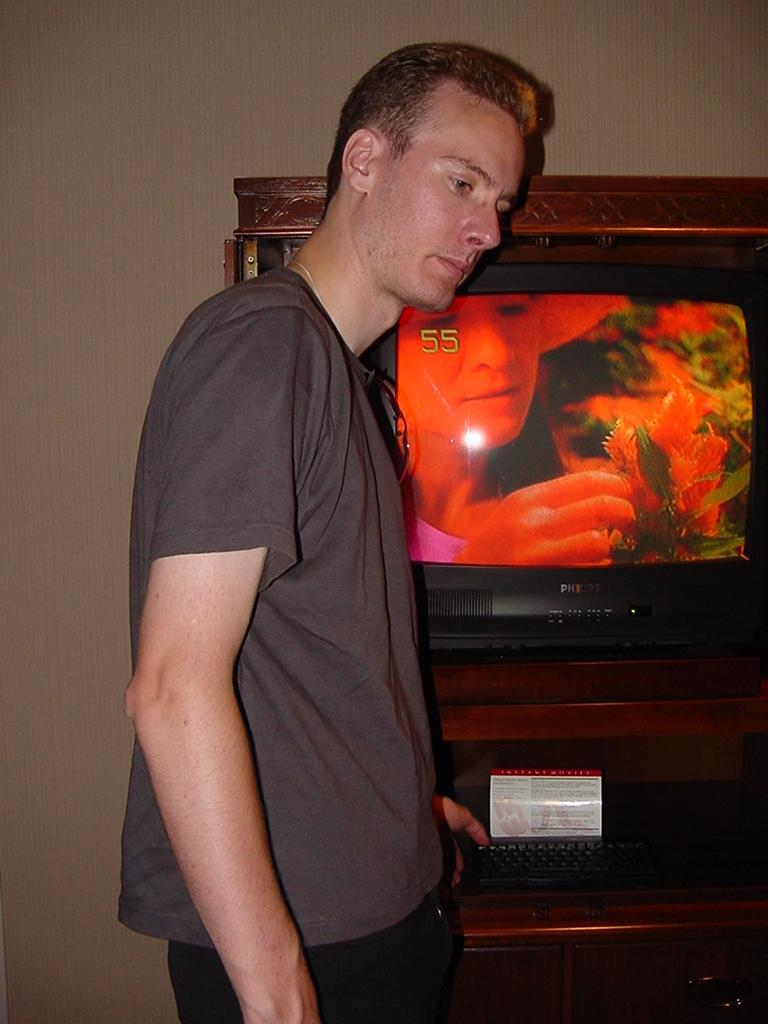What is the main subject of the image? There is a person standing in the middle of the image. What is located beside the person? There is a wall beside the person. What is on the wall? There is a screen on the wall. What type of test can be seen on the screen in the image? There is no test visible on the screen in the image. Can you hear a bell ringing in the image? There is no auditory information provided in the image, so it is impossible to determine if a bell is ringing. 